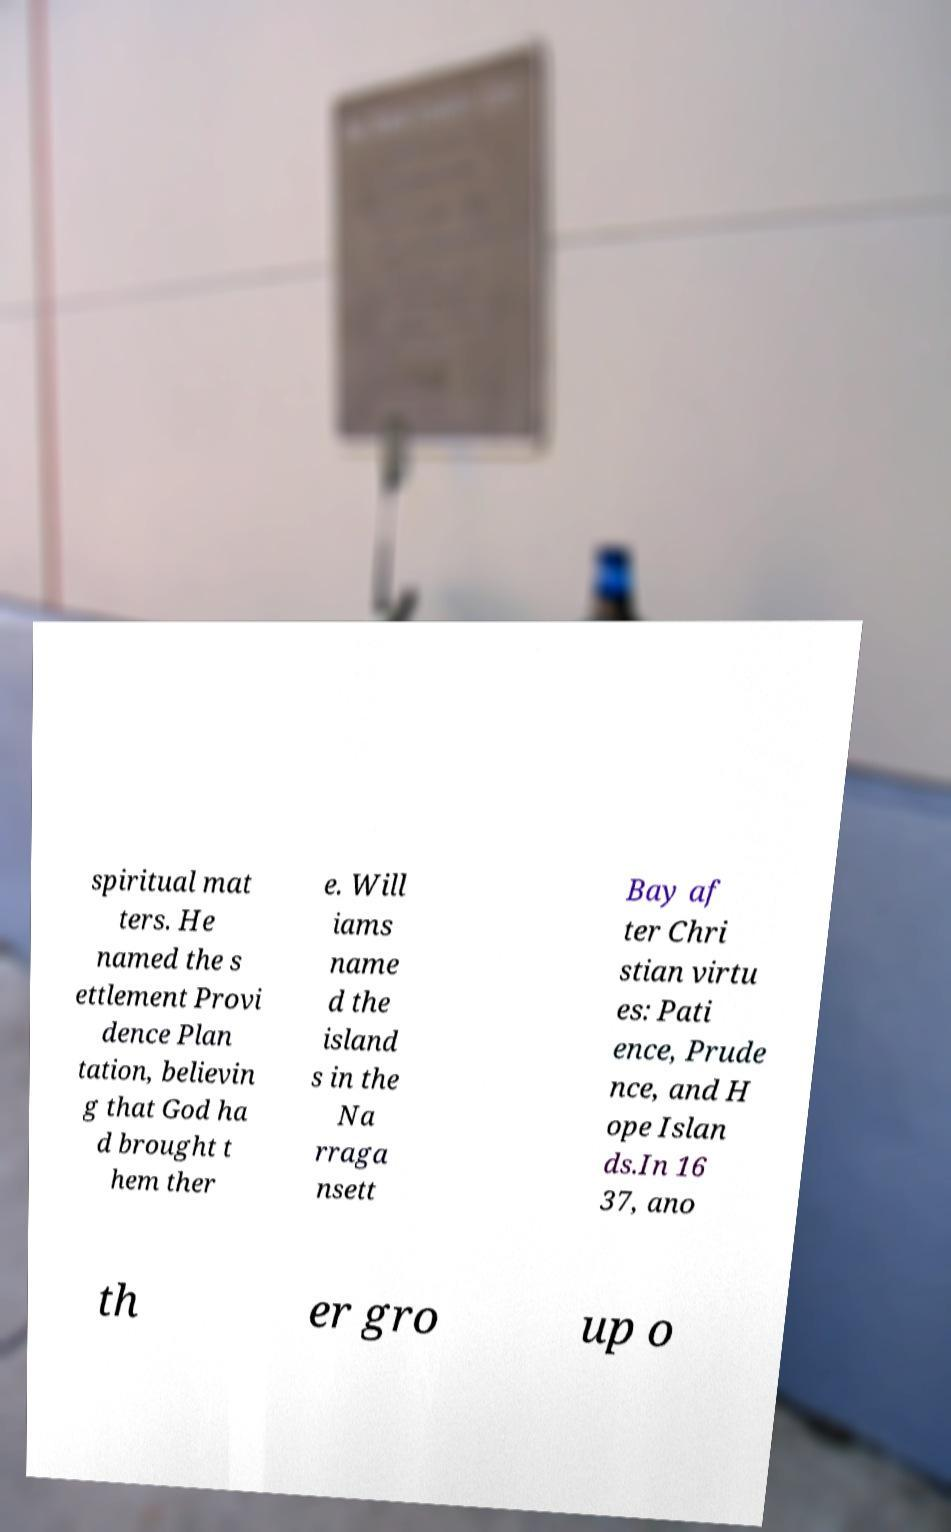Please read and relay the text visible in this image. What does it say? spiritual mat ters. He named the s ettlement Provi dence Plan tation, believin g that God ha d brought t hem ther e. Will iams name d the island s in the Na rraga nsett Bay af ter Chri stian virtu es: Pati ence, Prude nce, and H ope Islan ds.In 16 37, ano th er gro up o 